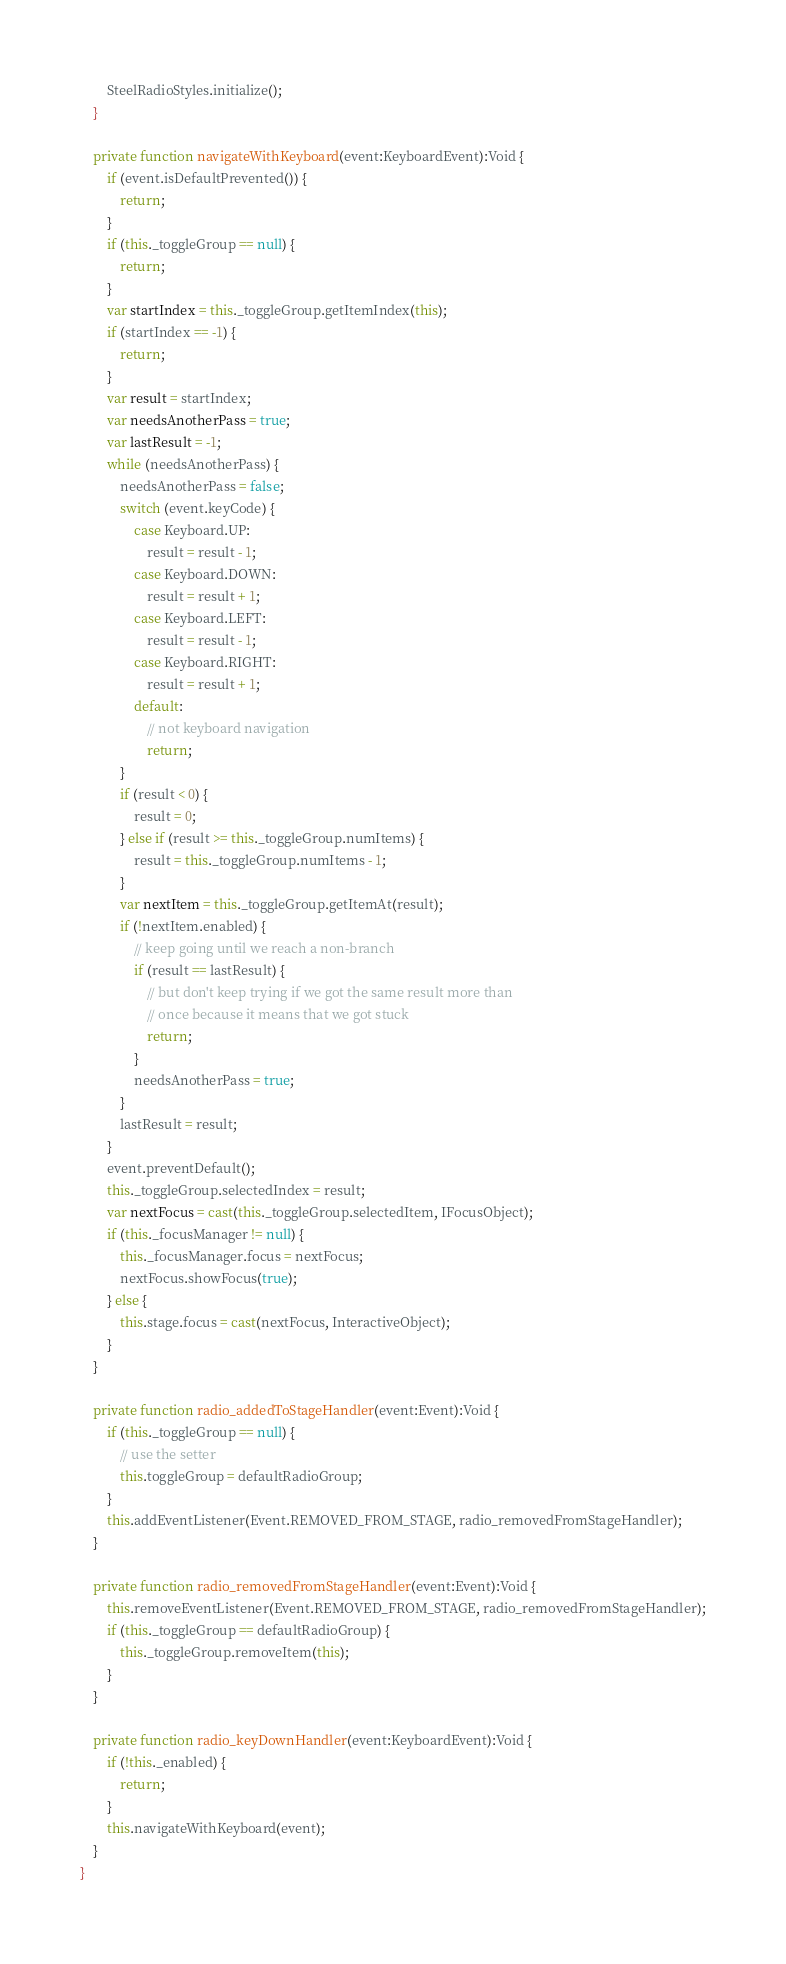Convert code to text. <code><loc_0><loc_0><loc_500><loc_500><_Haxe_>		SteelRadioStyles.initialize();
	}

	private function navigateWithKeyboard(event:KeyboardEvent):Void {
		if (event.isDefaultPrevented()) {
			return;
		}
		if (this._toggleGroup == null) {
			return;
		}
		var startIndex = this._toggleGroup.getItemIndex(this);
		if (startIndex == -1) {
			return;
		}
		var result = startIndex;
		var needsAnotherPass = true;
		var lastResult = -1;
		while (needsAnotherPass) {
			needsAnotherPass = false;
			switch (event.keyCode) {
				case Keyboard.UP:
					result = result - 1;
				case Keyboard.DOWN:
					result = result + 1;
				case Keyboard.LEFT:
					result = result - 1;
				case Keyboard.RIGHT:
					result = result + 1;
				default:
					// not keyboard navigation
					return;
			}
			if (result < 0) {
				result = 0;
			} else if (result >= this._toggleGroup.numItems) {
				result = this._toggleGroup.numItems - 1;
			}
			var nextItem = this._toggleGroup.getItemAt(result);
			if (!nextItem.enabled) {
				// keep going until we reach a non-branch
				if (result == lastResult) {
					// but don't keep trying if we got the same result more than
					// once because it means that we got stuck
					return;
				}
				needsAnotherPass = true;
			}
			lastResult = result;
		}
		event.preventDefault();
		this._toggleGroup.selectedIndex = result;
		var nextFocus = cast(this._toggleGroup.selectedItem, IFocusObject);
		if (this._focusManager != null) {
			this._focusManager.focus = nextFocus;
			nextFocus.showFocus(true);
		} else {
			this.stage.focus = cast(nextFocus, InteractiveObject);
		}
	}

	private function radio_addedToStageHandler(event:Event):Void {
		if (this._toggleGroup == null) {
			// use the setter
			this.toggleGroup = defaultRadioGroup;
		}
		this.addEventListener(Event.REMOVED_FROM_STAGE, radio_removedFromStageHandler);
	}

	private function radio_removedFromStageHandler(event:Event):Void {
		this.removeEventListener(Event.REMOVED_FROM_STAGE, radio_removedFromStageHandler);
		if (this._toggleGroup == defaultRadioGroup) {
			this._toggleGroup.removeItem(this);
		}
	}

	private function radio_keyDownHandler(event:KeyboardEvent):Void {
		if (!this._enabled) {
			return;
		}
		this.navigateWithKeyboard(event);
	}
}
</code> 